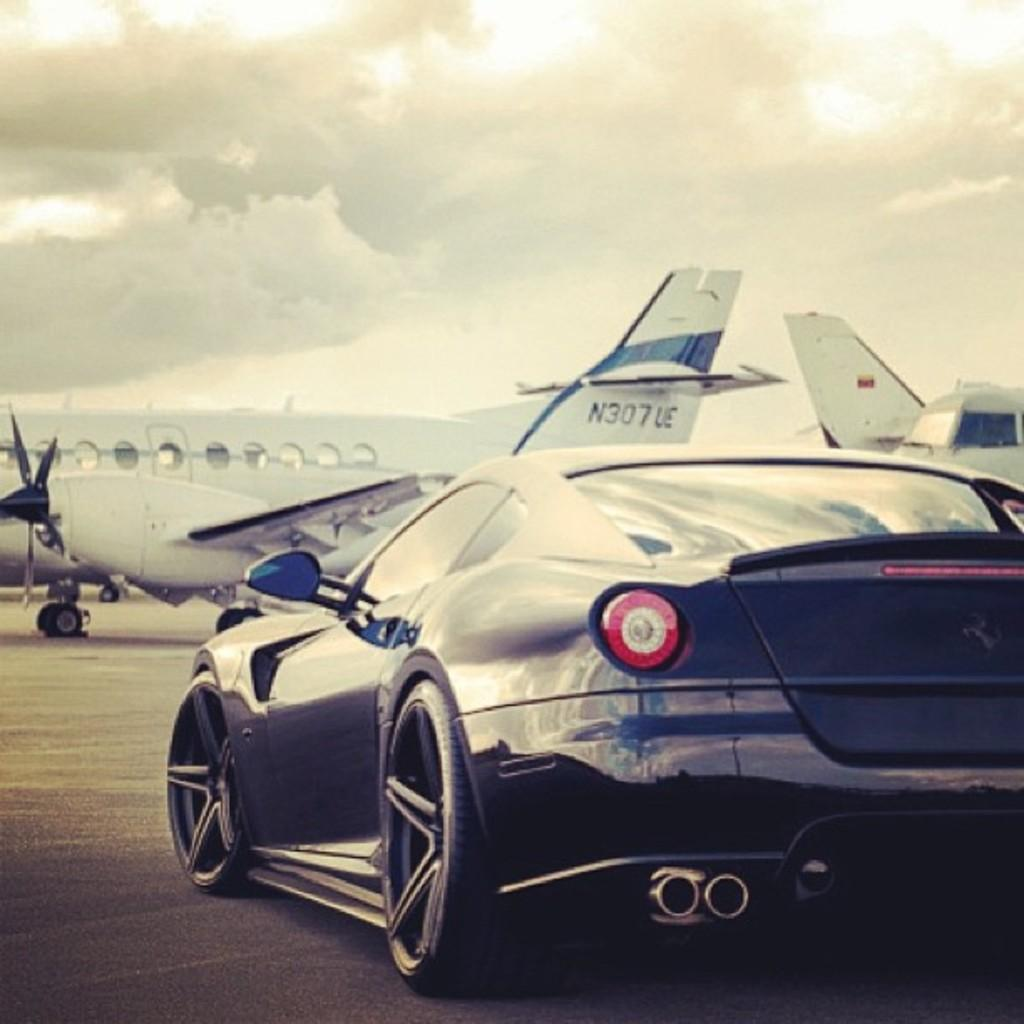<image>
Write a terse but informative summary of the picture. A sports car is shown with jet N307 UE in the background. 